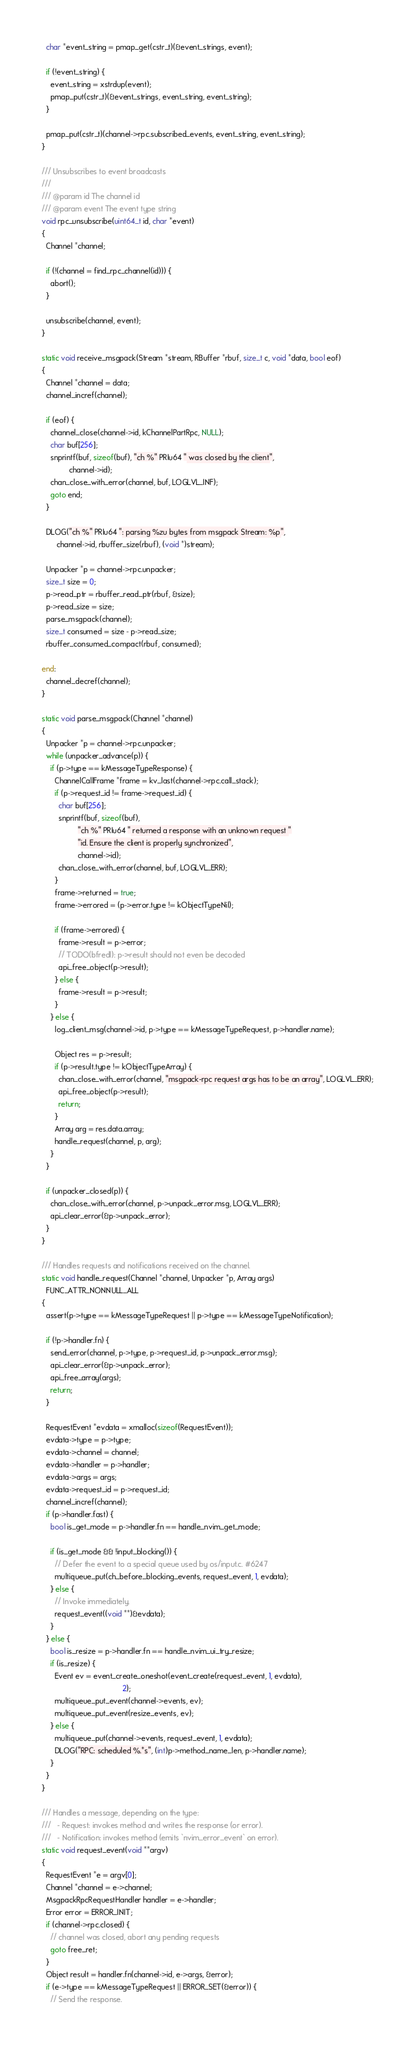<code> <loc_0><loc_0><loc_500><loc_500><_C_>  char *event_string = pmap_get(cstr_t)(&event_strings, event);

  if (!event_string) {
    event_string = xstrdup(event);
    pmap_put(cstr_t)(&event_strings, event_string, event_string);
  }

  pmap_put(cstr_t)(channel->rpc.subscribed_events, event_string, event_string);
}

/// Unsubscribes to event broadcasts
///
/// @param id The channel id
/// @param event The event type string
void rpc_unsubscribe(uint64_t id, char *event)
{
  Channel *channel;

  if (!(channel = find_rpc_channel(id))) {
    abort();
  }

  unsubscribe(channel, event);
}

static void receive_msgpack(Stream *stream, RBuffer *rbuf, size_t c, void *data, bool eof)
{
  Channel *channel = data;
  channel_incref(channel);

  if (eof) {
    channel_close(channel->id, kChannelPartRpc, NULL);
    char buf[256];
    snprintf(buf, sizeof(buf), "ch %" PRIu64 " was closed by the client",
             channel->id);
    chan_close_with_error(channel, buf, LOGLVL_INF);
    goto end;
  }

  DLOG("ch %" PRIu64 ": parsing %zu bytes from msgpack Stream: %p",
       channel->id, rbuffer_size(rbuf), (void *)stream);

  Unpacker *p = channel->rpc.unpacker;
  size_t size = 0;
  p->read_ptr = rbuffer_read_ptr(rbuf, &size);
  p->read_size = size;
  parse_msgpack(channel);
  size_t consumed = size - p->read_size;
  rbuffer_consumed_compact(rbuf, consumed);

end:
  channel_decref(channel);
}

static void parse_msgpack(Channel *channel)
{
  Unpacker *p = channel->rpc.unpacker;
  while (unpacker_advance(p)) {
    if (p->type == kMessageTypeResponse) {
      ChannelCallFrame *frame = kv_last(channel->rpc.call_stack);
      if (p->request_id != frame->request_id) {
        char buf[256];
        snprintf(buf, sizeof(buf),
                 "ch %" PRIu64 " returned a response with an unknown request "
                 "id. Ensure the client is properly synchronized",
                 channel->id);
        chan_close_with_error(channel, buf, LOGLVL_ERR);
      }
      frame->returned = true;
      frame->errored = (p->error.type != kObjectTypeNil);

      if (frame->errored) {
        frame->result = p->error;
        // TODO(bfredl): p->result should not even be decoded
        api_free_object(p->result);
      } else {
        frame->result = p->result;
      }
    } else {
      log_client_msg(channel->id, p->type == kMessageTypeRequest, p->handler.name);

      Object res = p->result;
      if (p->result.type != kObjectTypeArray) {
        chan_close_with_error(channel, "msgpack-rpc request args has to be an array", LOGLVL_ERR);
        api_free_object(p->result);
        return;
      }
      Array arg = res.data.array;
      handle_request(channel, p, arg);
    }
  }

  if (unpacker_closed(p)) {
    chan_close_with_error(channel, p->unpack_error.msg, LOGLVL_ERR);
    api_clear_error(&p->unpack_error);
  }
}

/// Handles requests and notifications received on the channel.
static void handle_request(Channel *channel, Unpacker *p, Array args)
  FUNC_ATTR_NONNULL_ALL
{
  assert(p->type == kMessageTypeRequest || p->type == kMessageTypeNotification);

  if (!p->handler.fn) {
    send_error(channel, p->type, p->request_id, p->unpack_error.msg);
    api_clear_error(&p->unpack_error);
    api_free_array(args);
    return;
  }

  RequestEvent *evdata = xmalloc(sizeof(RequestEvent));
  evdata->type = p->type;
  evdata->channel = channel;
  evdata->handler = p->handler;
  evdata->args = args;
  evdata->request_id = p->request_id;
  channel_incref(channel);
  if (p->handler.fast) {
    bool is_get_mode = p->handler.fn == handle_nvim_get_mode;

    if (is_get_mode && !input_blocking()) {
      // Defer the event to a special queue used by os/input.c. #6247
      multiqueue_put(ch_before_blocking_events, request_event, 1, evdata);
    } else {
      // Invoke immediately.
      request_event((void **)&evdata);
    }
  } else {
    bool is_resize = p->handler.fn == handle_nvim_ui_try_resize;
    if (is_resize) {
      Event ev = event_create_oneshot(event_create(request_event, 1, evdata),
                                      2);
      multiqueue_put_event(channel->events, ev);
      multiqueue_put_event(resize_events, ev);
    } else {
      multiqueue_put(channel->events, request_event, 1, evdata);
      DLOG("RPC: scheduled %.*s", (int)p->method_name_len, p->handler.name);
    }
  }
}

/// Handles a message, depending on the type:
///   - Request: invokes method and writes the response (or error).
///   - Notification: invokes method (emits `nvim_error_event` on error).
static void request_event(void **argv)
{
  RequestEvent *e = argv[0];
  Channel *channel = e->channel;
  MsgpackRpcRequestHandler handler = e->handler;
  Error error = ERROR_INIT;
  if (channel->rpc.closed) {
    // channel was closed, abort any pending requests
    goto free_ret;
  }
  Object result = handler.fn(channel->id, e->args, &error);
  if (e->type == kMessageTypeRequest || ERROR_SET(&error)) {
    // Send the response.</code> 